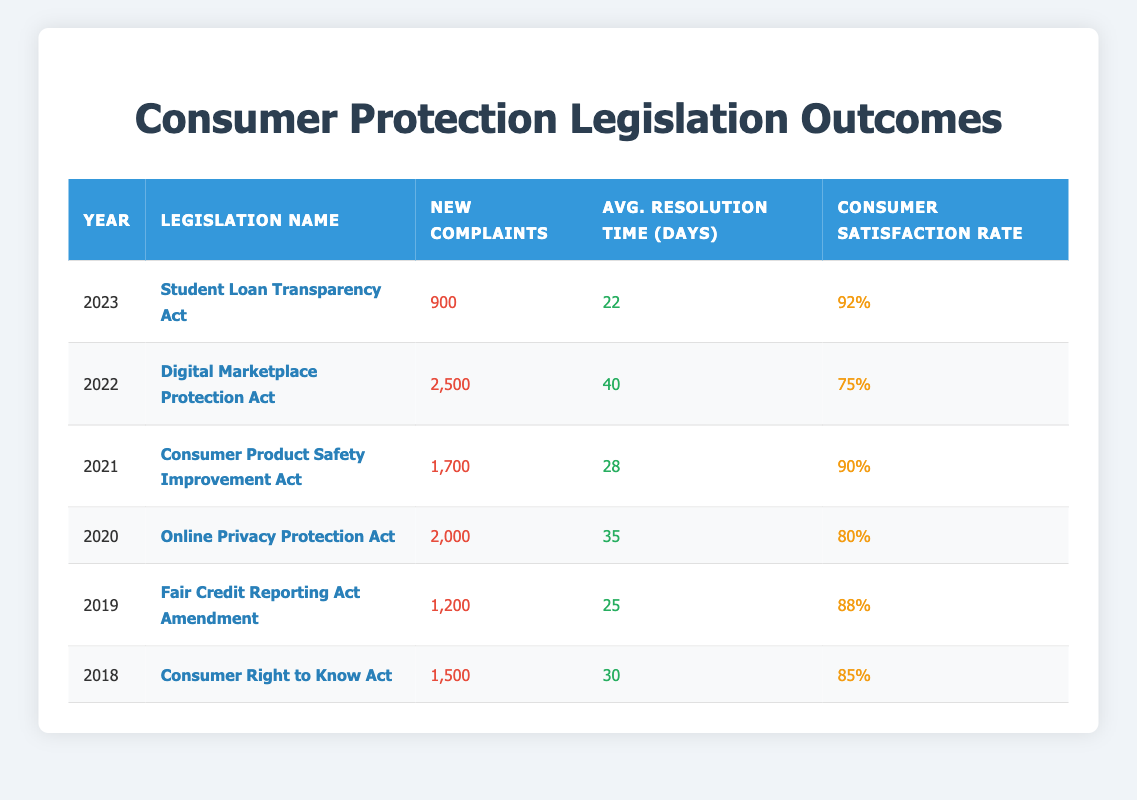What legislation had the highest number of new complaints registered? By reviewing the table, we can see that the Digital Marketplace Protection Act in 2022 had the highest number of new complaints registered at 2,500.
Answer: Digital Marketplace Protection Act What was the average resolution time for complaints in 2021? Looking at the table, the average resolution time for complaints in 2021, under the Consumer Product Safety Improvement Act, was 28 days.
Answer: 28 Is the consumer satisfaction rate for the Online Privacy Protection Act higher than that for the Consumer Right to Know Act? The consumer satisfaction rate for the Online Privacy Protection Act in 2020 was 80%, while the Consumer Right to Know Act in 2018 had a satisfaction rate of 85%. Since 80% is less than 85%, the answer is no.
Answer: No What is the total number of complaints registered from 2019 to 2022? To find the total number of complaints from 2019 to 2022, we add the new complaints registered for each year: 1,200 (2019) + 2,000 (2020) + 1,700 (2021) + 2,500 (2022) = 7,400.
Answer: 7,400 Which year had the lowest average resolution time, and what was it? By analyzing the table, we see that the year 2023 had the lowest average resolution time at 22 days for the Student Loan Transparency Act.
Answer: 22 Is it true that consumer satisfaction rates have improved from 2018 to 2023? By comparing consumer satisfaction rates, we see 85% in 2018 and 92% in 2023. Since 92% is higher than 85%, the statement is true.
Answer: Yes What legislation had the highest consumer satisfaction rate? The table indicates that the Student Loan Transparency Act in 2023 had the highest consumer satisfaction rate at 92%.
Answer: Student Loan Transparency Act What was the difference in new complaints registered between 2019 and 2020? To find the difference, we take the number of new complaints in 2020 (2,000) and subtract the number from 2019 (1,200): 2,000 - 1,200 = 800.
Answer: 800 